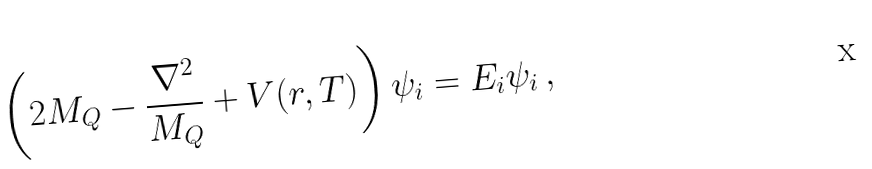<formula> <loc_0><loc_0><loc_500><loc_500>\left ( 2 M _ { Q } - \frac { \nabla ^ { 2 } } { M _ { Q } } + V ( r , T ) \right ) \psi _ { i } = E _ { i } \psi _ { i } \, ,</formula> 